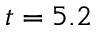Convert formula to latex. <formula><loc_0><loc_0><loc_500><loc_500>t = 5 . 2</formula> 